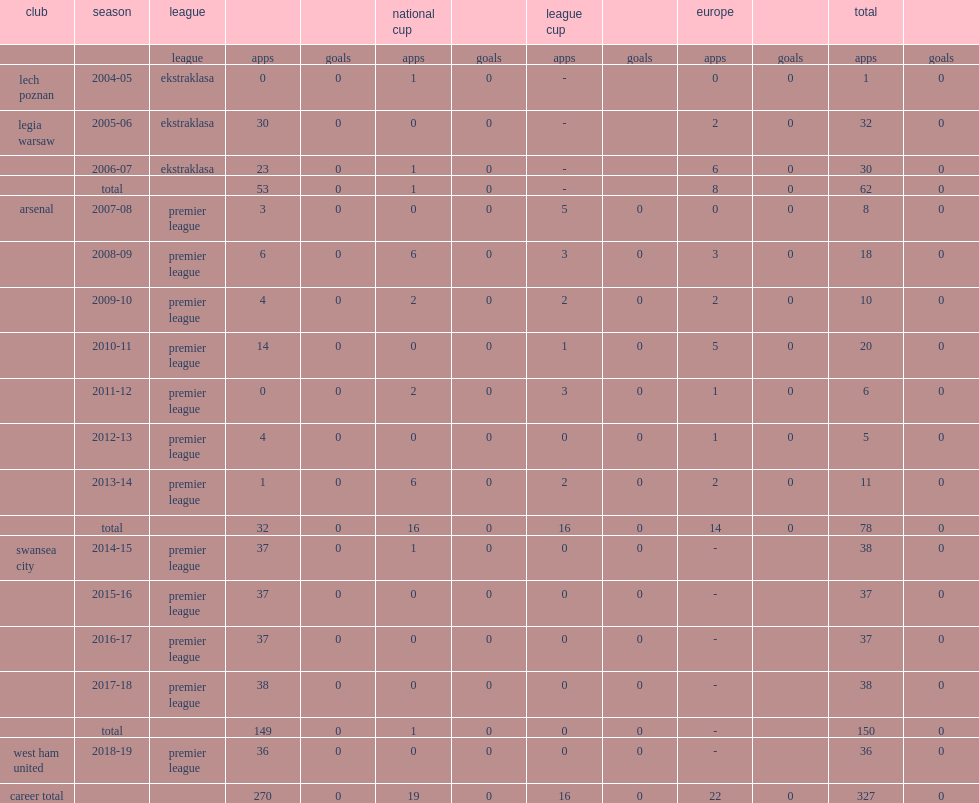During the 2013-14 season, which league did fabianski appear for arsenal? Premier league. 